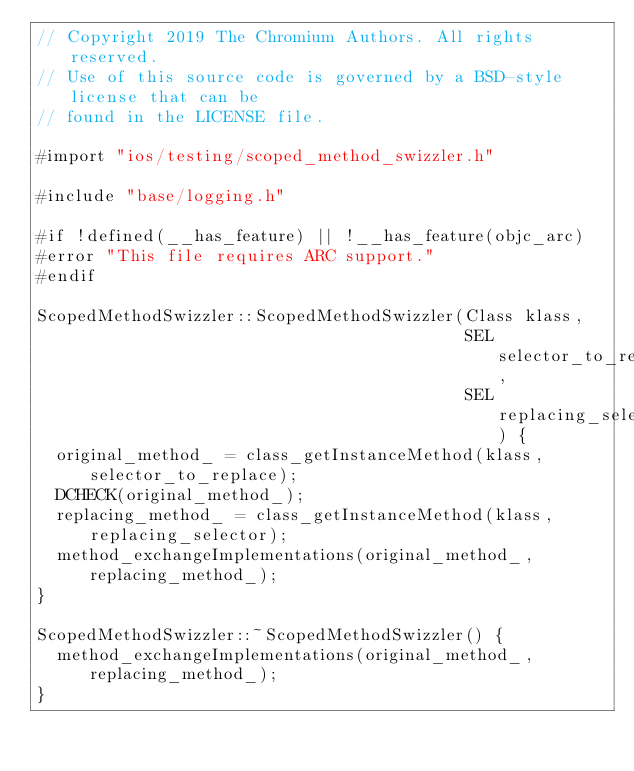Convert code to text. <code><loc_0><loc_0><loc_500><loc_500><_ObjectiveC_>// Copyright 2019 The Chromium Authors. All rights reserved.
// Use of this source code is governed by a BSD-style license that can be
// found in the LICENSE file.

#import "ios/testing/scoped_method_swizzler.h"

#include "base/logging.h"

#if !defined(__has_feature) || !__has_feature(objc_arc)
#error "This file requires ARC support."
#endif

ScopedMethodSwizzler::ScopedMethodSwizzler(Class klass,
                                           SEL selector_to_replace,
                                           SEL replacing_selector) {
  original_method_ = class_getInstanceMethod(klass, selector_to_replace);
  DCHECK(original_method_);
  replacing_method_ = class_getInstanceMethod(klass, replacing_selector);
  method_exchangeImplementations(original_method_, replacing_method_);
}

ScopedMethodSwizzler::~ScopedMethodSwizzler() {
  method_exchangeImplementations(original_method_, replacing_method_);
}
</code> 